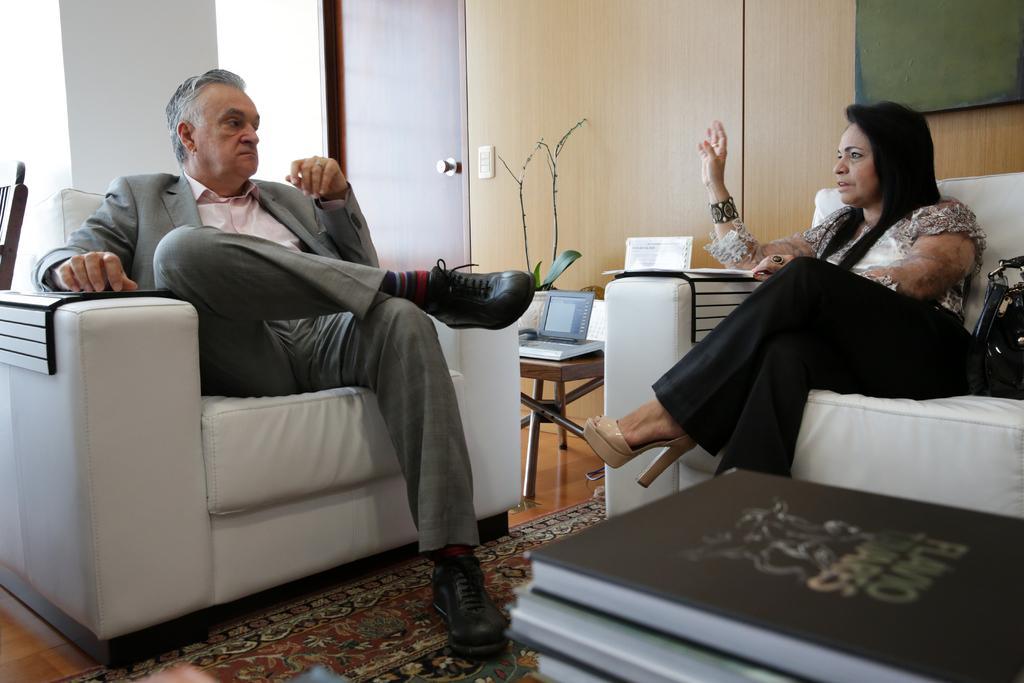How would you summarize this image in a sentence or two? In this image i can see a man sitting on the couch and a woman sitting on the couch. In the background i can see a wall and a plant. 